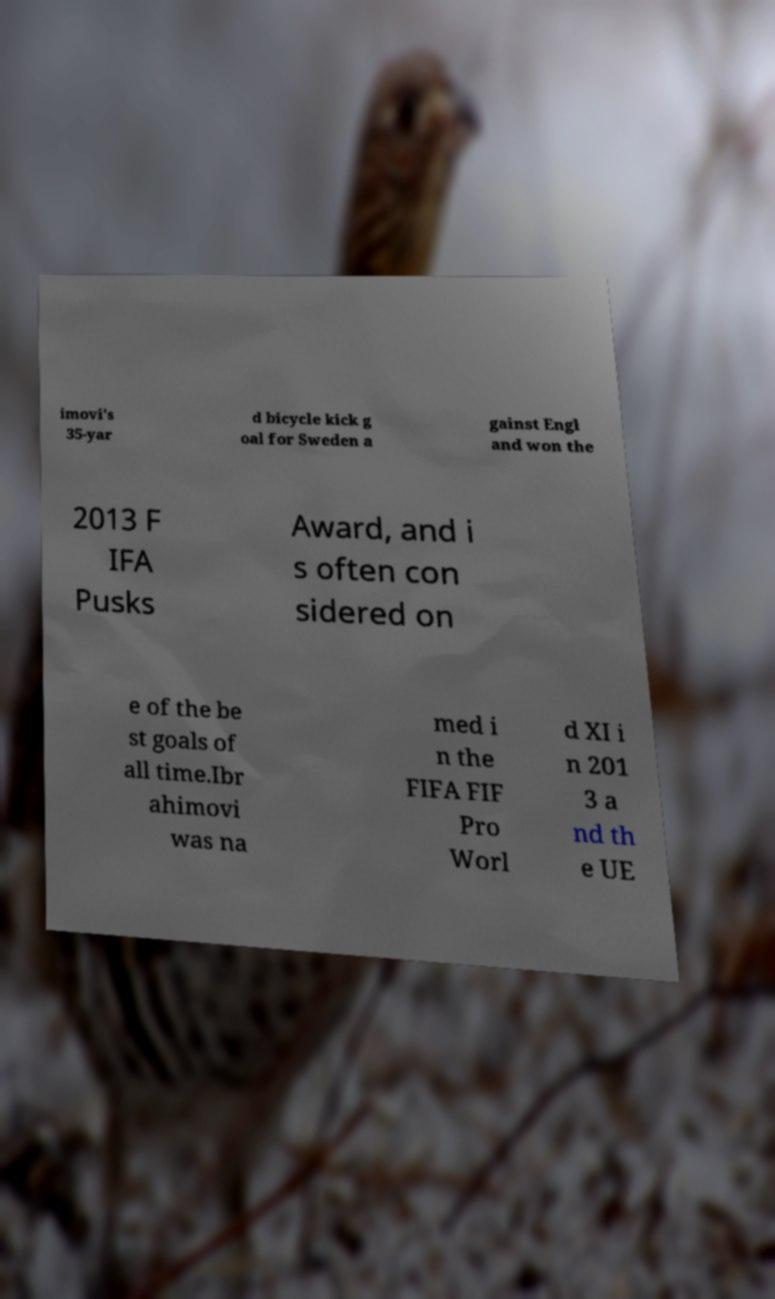Please read and relay the text visible in this image. What does it say? imovi's 35-yar d bicycle kick g oal for Sweden a gainst Engl and won the 2013 F IFA Pusks Award, and i s often con sidered on e of the be st goals of all time.Ibr ahimovi was na med i n the FIFA FIF Pro Worl d XI i n 201 3 a nd th e UE 